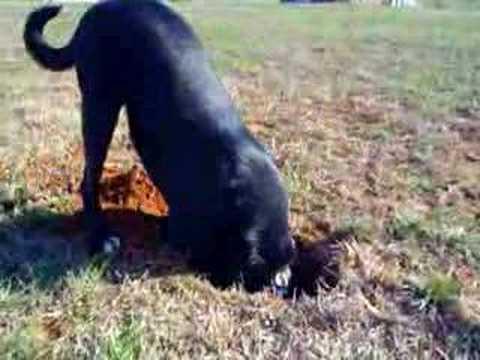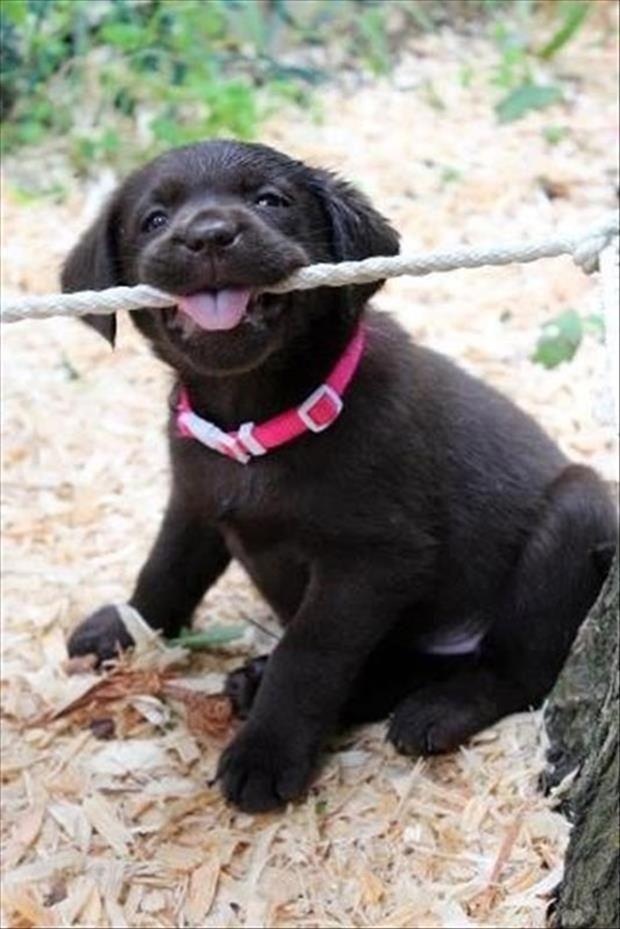The first image is the image on the left, the second image is the image on the right. For the images shown, is this caption "The right image contains more than one dog, and the left image features a dog with fangs bared in a snarl." true? Answer yes or no. No. The first image is the image on the left, the second image is the image on the right. Assess this claim about the two images: "There is no more than two dogs in the right image.". Correct or not? Answer yes or no. Yes. 